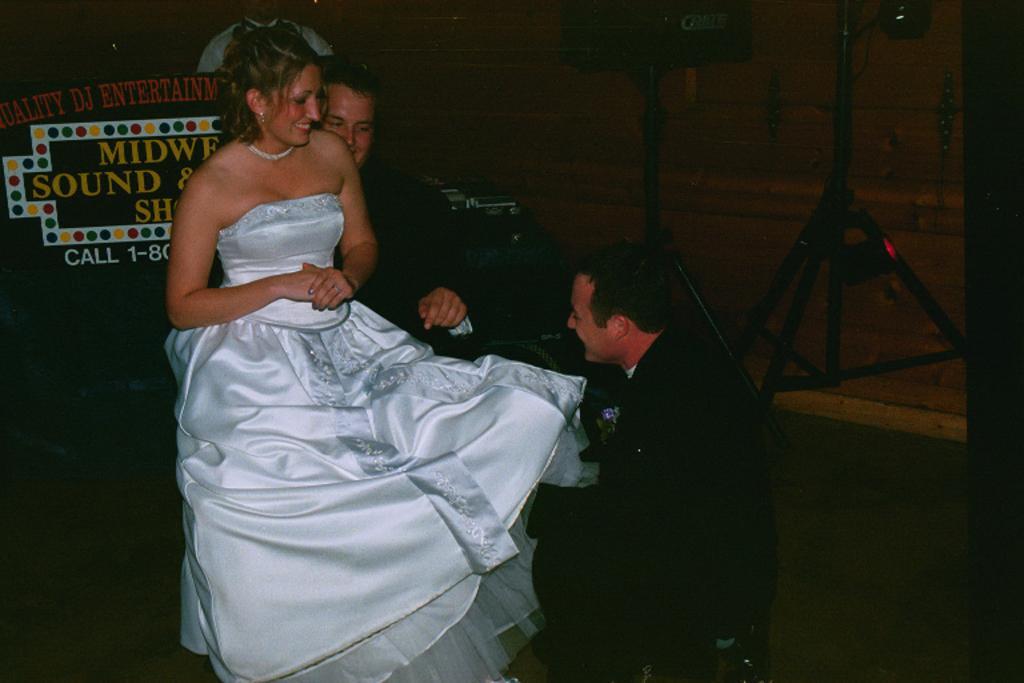Could you give a brief overview of what you see in this image? In the image there is a man with black dress is sitting on the floor. In front of him there is a lady with white frock is sitting on the person who is wearing a black dress. In the background there are black stands. 